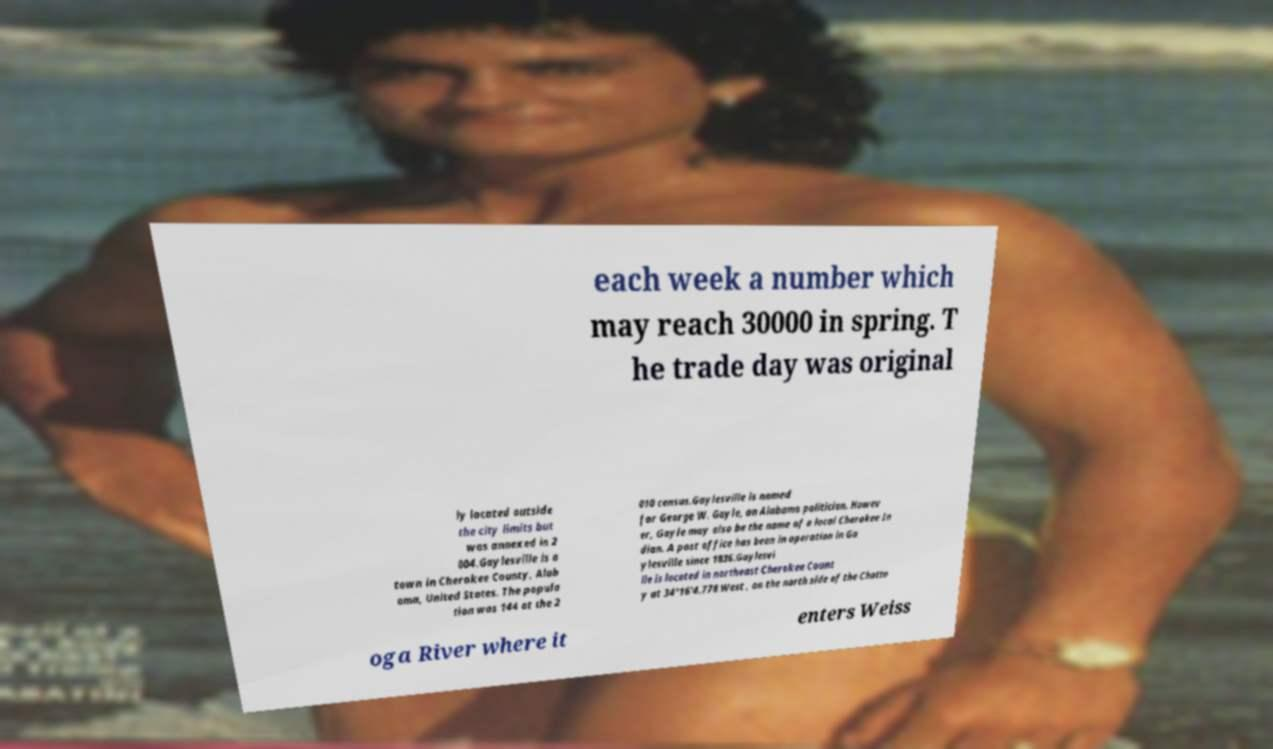Could you assist in decoding the text presented in this image and type it out clearly? each week a number which may reach 30000 in spring. T he trade day was original ly located outside the city limits but was annexed in 2 004.Gaylesville is a town in Cherokee County, Alab ama, United States. The popula tion was 144 at the 2 010 census.Gaylesville is named for George W. Gayle, an Alabama politician. Howev er, Gayle may also be the name of a local Cherokee In dian. A post office has been in operation in Ga ylesville since 1836.Gaylesvi lle is located in northeast Cherokee Count y at 34°16'4.778 West , on the north side of the Chatto oga River where it enters Weiss 